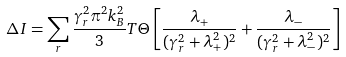<formula> <loc_0><loc_0><loc_500><loc_500>\Delta I = \sum _ { r } \frac { \gamma _ { r } ^ { 2 } \pi ^ { 2 } k _ { B } ^ { 2 } } { 3 } T \Theta \left [ \frac { \lambda _ { + } } { ( \gamma _ { r } ^ { 2 } + \lambda _ { + } ^ { 2 } ) ^ { 2 } } + \frac { \lambda _ { - } } { ( \gamma _ { r } ^ { 2 } + \lambda _ { - } ^ { 2 } ) ^ { 2 } } \right ]</formula> 